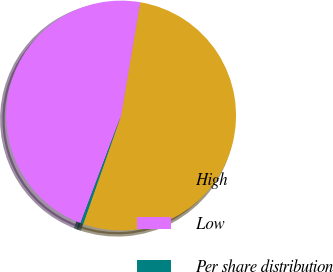<chart> <loc_0><loc_0><loc_500><loc_500><pie_chart><fcel>High<fcel>Low<fcel>Per share distribution<nl><fcel>52.7%<fcel>46.92%<fcel>0.38%<nl></chart> 